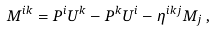<formula> <loc_0><loc_0><loc_500><loc_500>M ^ { i k } = P ^ { i } U ^ { k } - P ^ { k } U ^ { i } - \eta ^ { i k j } M _ { j } \, ,</formula> 